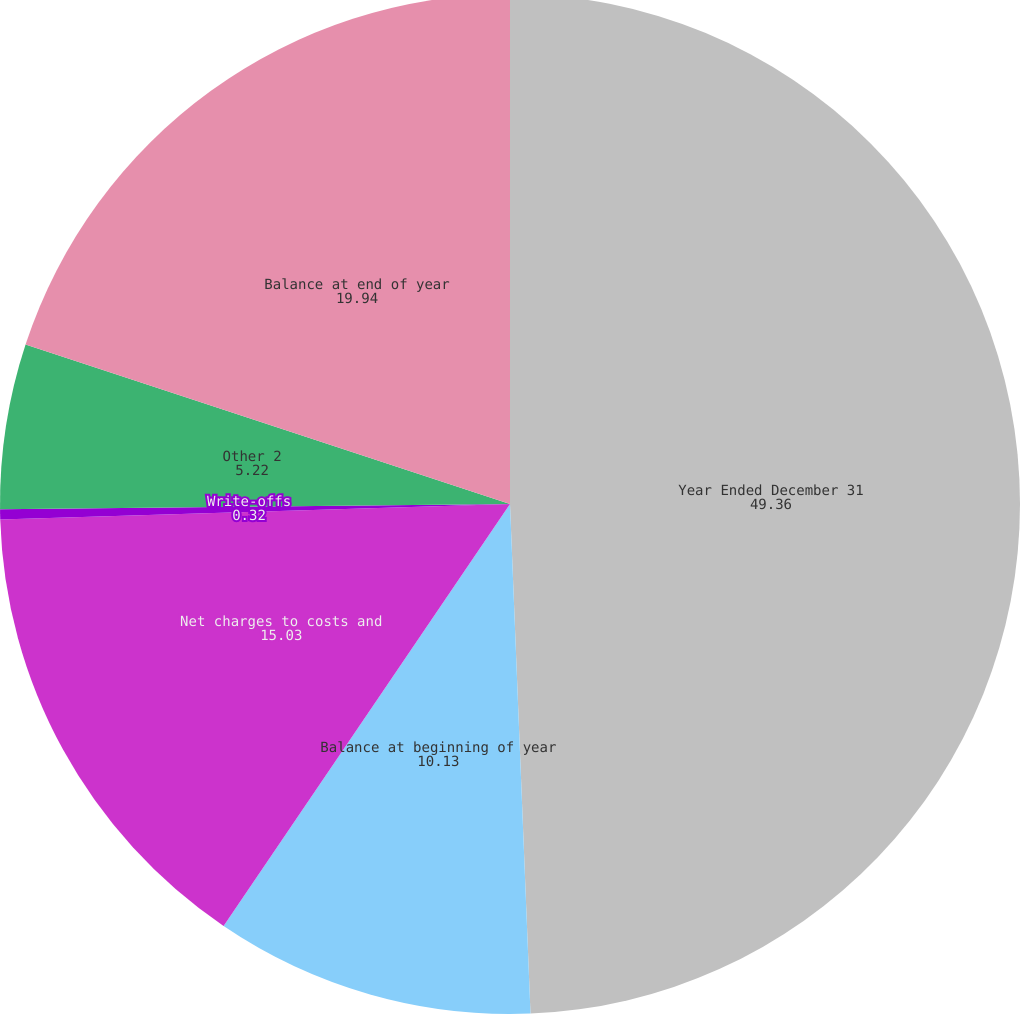<chart> <loc_0><loc_0><loc_500><loc_500><pie_chart><fcel>Year Ended December 31<fcel>Balance at beginning of year<fcel>Net charges to costs and<fcel>Write-offs<fcel>Other 2<fcel>Balance at end of year<nl><fcel>49.36%<fcel>10.13%<fcel>15.03%<fcel>0.32%<fcel>5.22%<fcel>19.94%<nl></chart> 